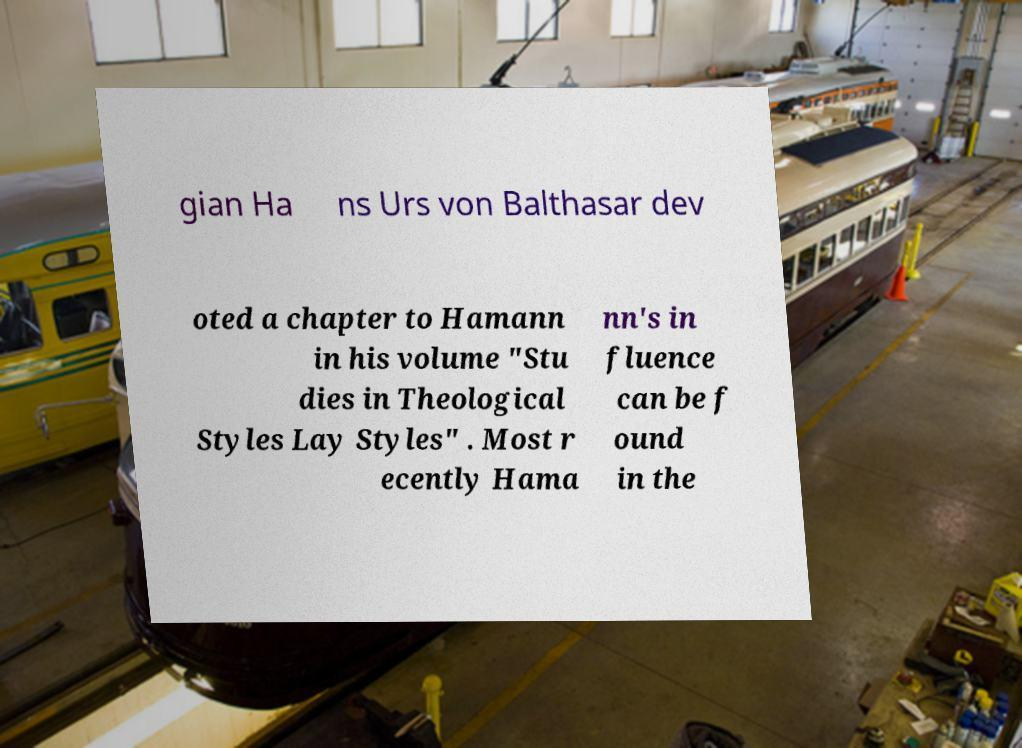Could you assist in decoding the text presented in this image and type it out clearly? gian Ha ns Urs von Balthasar dev oted a chapter to Hamann in his volume "Stu dies in Theological Styles Lay Styles" . Most r ecently Hama nn's in fluence can be f ound in the 